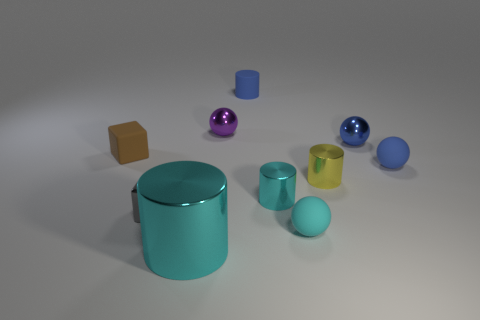Subtract all spheres. How many objects are left? 6 Add 2 big shiny objects. How many big shiny objects are left? 3 Add 6 tiny cyan rubber objects. How many tiny cyan rubber objects exist? 7 Subtract 1 purple spheres. How many objects are left? 9 Subtract all tiny green blocks. Subtract all tiny blue rubber balls. How many objects are left? 9 